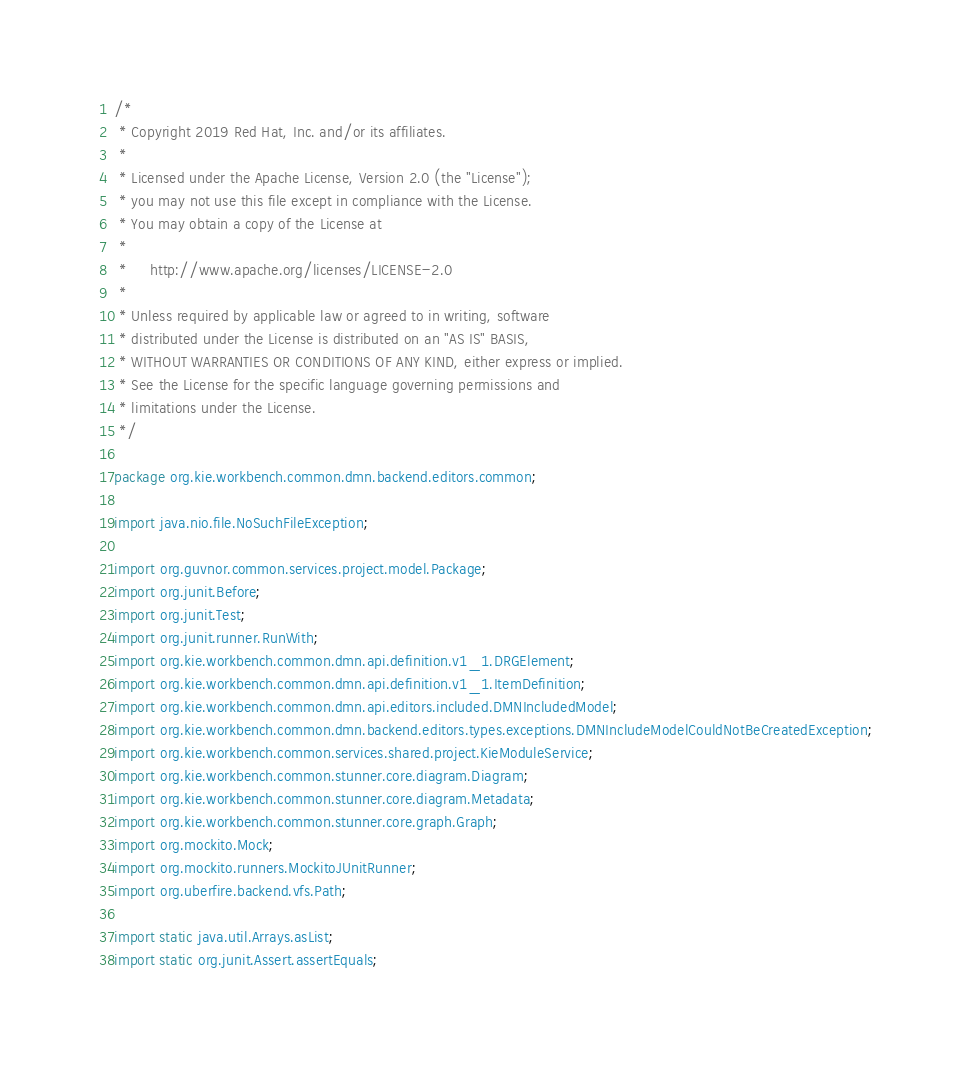Convert code to text. <code><loc_0><loc_0><loc_500><loc_500><_Java_>/*
 * Copyright 2019 Red Hat, Inc. and/or its affiliates.
 *
 * Licensed under the Apache License, Version 2.0 (the "License");
 * you may not use this file except in compliance with the License.
 * You may obtain a copy of the License at
 *
 *     http://www.apache.org/licenses/LICENSE-2.0
 *
 * Unless required by applicable law or agreed to in writing, software
 * distributed under the License is distributed on an "AS IS" BASIS,
 * WITHOUT WARRANTIES OR CONDITIONS OF ANY KIND, either express or implied.
 * See the License for the specific language governing permissions and
 * limitations under the License.
 */

package org.kie.workbench.common.dmn.backend.editors.common;

import java.nio.file.NoSuchFileException;

import org.guvnor.common.services.project.model.Package;
import org.junit.Before;
import org.junit.Test;
import org.junit.runner.RunWith;
import org.kie.workbench.common.dmn.api.definition.v1_1.DRGElement;
import org.kie.workbench.common.dmn.api.definition.v1_1.ItemDefinition;
import org.kie.workbench.common.dmn.api.editors.included.DMNIncludedModel;
import org.kie.workbench.common.dmn.backend.editors.types.exceptions.DMNIncludeModelCouldNotBeCreatedException;
import org.kie.workbench.common.services.shared.project.KieModuleService;
import org.kie.workbench.common.stunner.core.diagram.Diagram;
import org.kie.workbench.common.stunner.core.diagram.Metadata;
import org.kie.workbench.common.stunner.core.graph.Graph;
import org.mockito.Mock;
import org.mockito.runners.MockitoJUnitRunner;
import org.uberfire.backend.vfs.Path;

import static java.util.Arrays.asList;
import static org.junit.Assert.assertEquals;</code> 